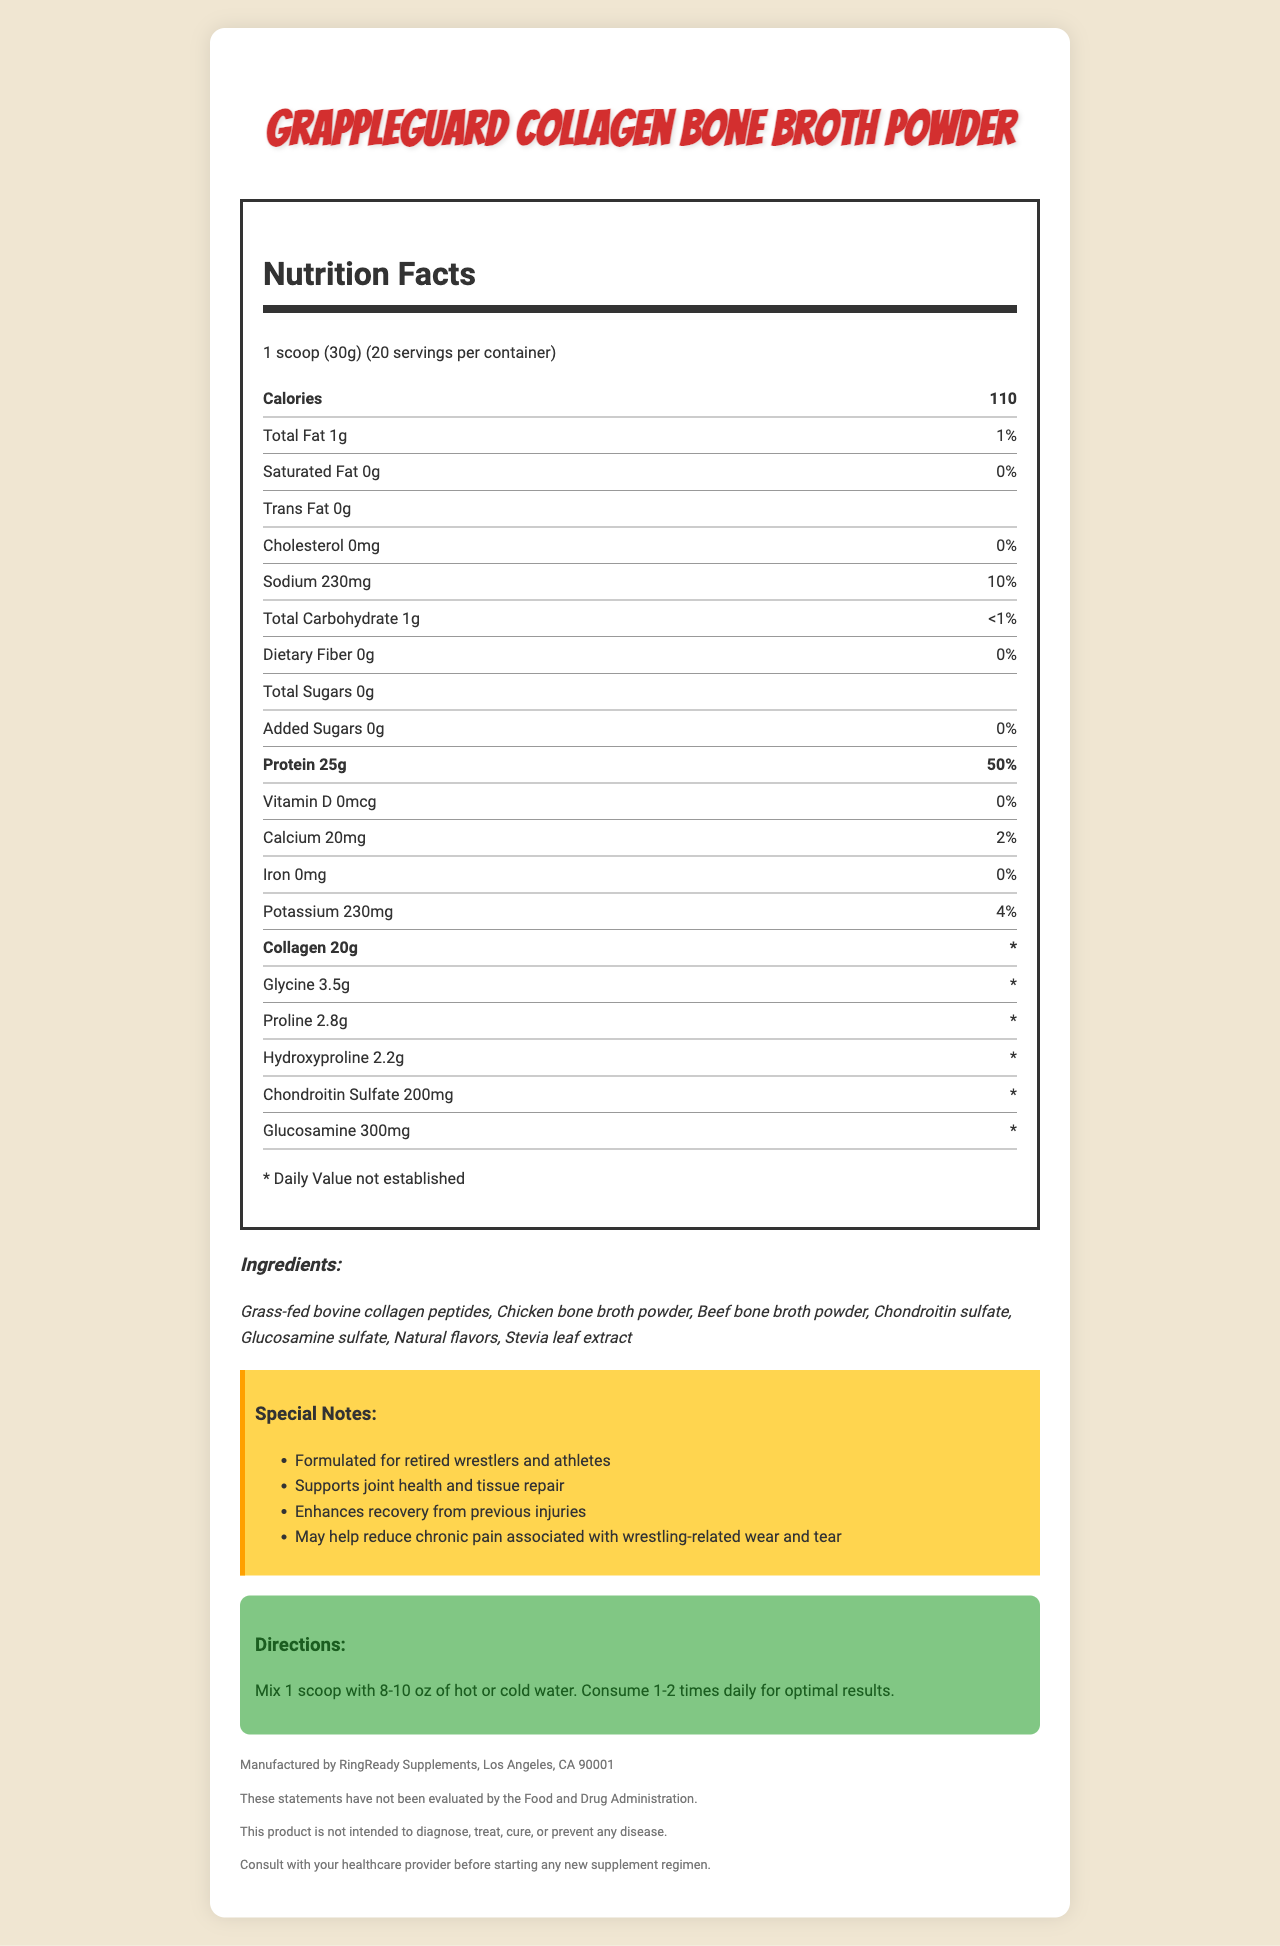what is the serving size? The serving size is listed at the beginning of the Nutrition Facts section under "serving size."
Answer: 1 scoop (30g) how many servings are there per container? The document states that there are 20 servings per container right after the serving size information.
Answer: 20 what is the protein content per serving? The protein content per serving is specified as 25g in the Nutrition Facts section.
Answer: 25g what is the percentage daily value of sodium? The percentage daily value of sodium is listed as 10% in the Nutrition Facts section.
Answer: 10% how many grams of collagen are in one serving? The amount of collagen per serving is stated as 20g in the Nutrition Facts section.
Answer: 20g which of the following ingredients is used in this product? A. Sugars B. Stevia leaf extract C. Preservatives The listed ingredients include "Stevia leaf extract," whereas sugars and preservatives are not mentioned.
Answer: B how many calories does one serving provide? i. 50 ii. 75 iii. 110 iv. 130 The number of calories per serving is listed as 110 in the Nutrition Facts section.
Answer: iii does the product contain any trans fat? (Yes/No) The Nutrition Facts section indicates that the trans fat content is 0g.
Answer: No summarize the purpose of this product. The special notes section mentions that the product is formulated for retired wrestlers and athletes, supports joint health, enhances recovery from injuries, and may help reduce chronic pain.
Answer: Supports joint health and tissue repair, especially for retired wrestlers and athletes, to aid in recovery from previous injuries and reduce chronic pain. what is the source of the collagen peptides used in this product? The ingredients section lists "Grass-fed bovine collagen peptides" as one of the sources of collagen.
Answer: Grass-fed bovine collagen what is the potassium content per serving in percentage daily value? The potassium content per serving is listed as 4% of the daily value in the Nutrition Facts section.
Answer: 4% is this product free from common allergens? The allergen information section states "Contains: None," indicating the product does not contain common allergens.
Answer: Yes what is the main ingredient responsible for supporting joint health in this product? The ingredients section lists chondroitin sulfate and glucosamine sulfate, which are known to support joint health.
Answer: Chondroitin sulfate and Glucosamine sulfate can I find out how much daily value of collagen is recommended? The daily value footnote states that the Daily Value for collagen is not established, hence the recommended daily value cannot be determined from the document.
Answer: Cannot be determined who manufactures this product? The manufacturer information is listed at the end of the document under the disclaimers section.
Answer: RingReady Supplements, Los Angeles, CA 90001 